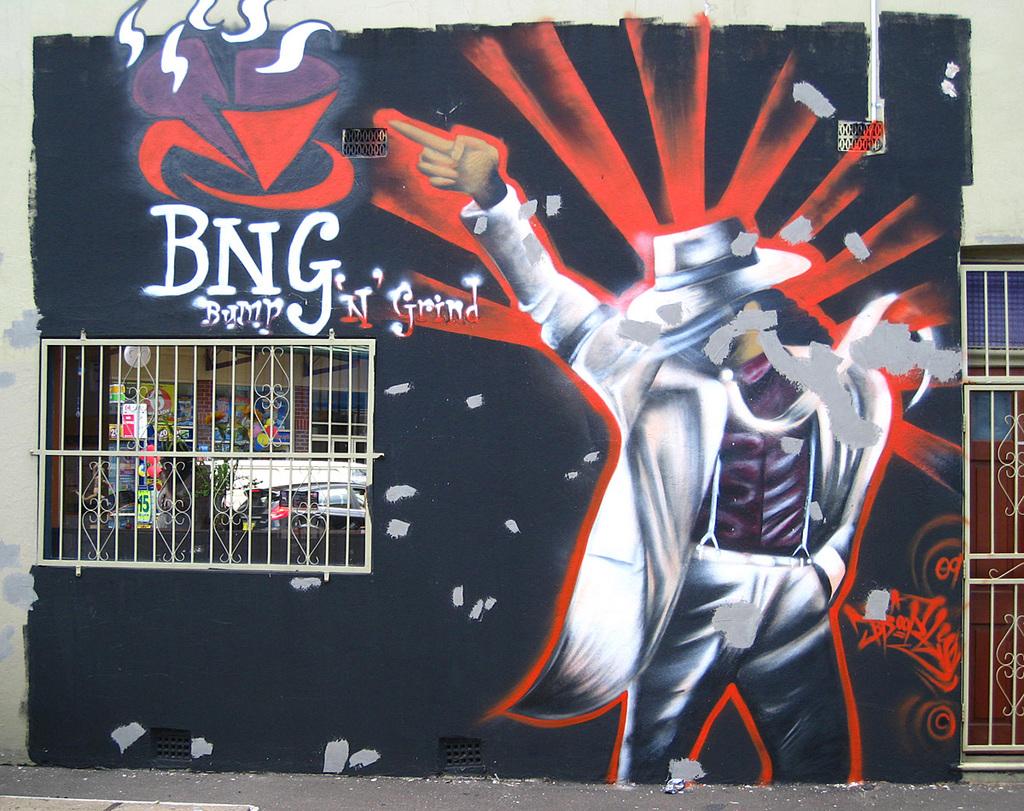What does it say on the wall?
Offer a very short reply. Bng bump 'n' grind. What does bng stand for?
Offer a very short reply. Bump n grind. 